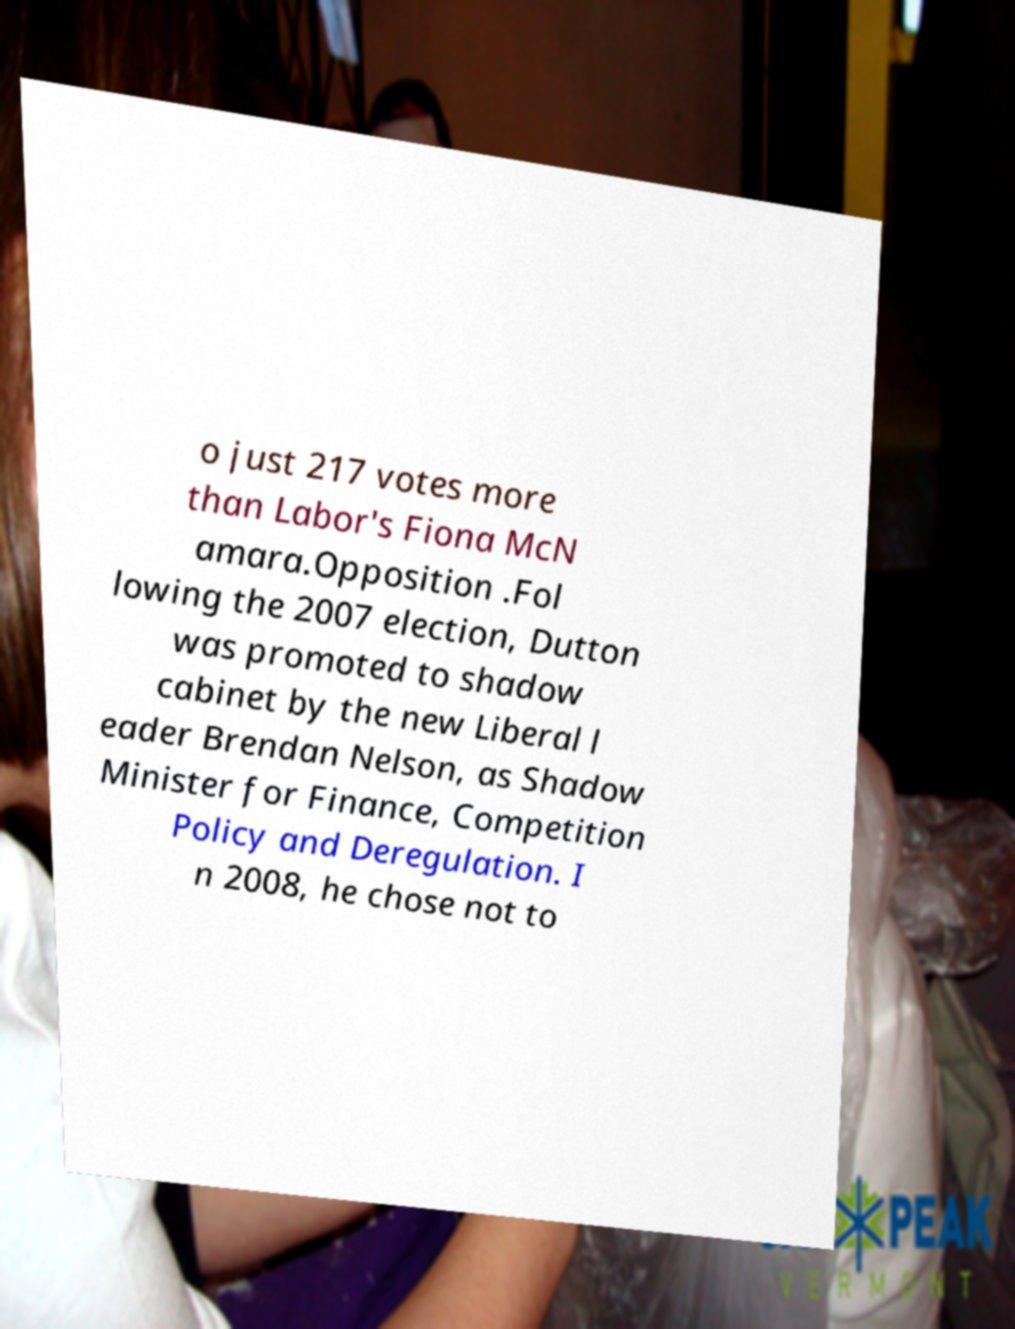Can you read and provide the text displayed in the image?This photo seems to have some interesting text. Can you extract and type it out for me? o just 217 votes more than Labor's Fiona McN amara.Opposition .Fol lowing the 2007 election, Dutton was promoted to shadow cabinet by the new Liberal l eader Brendan Nelson, as Shadow Minister for Finance, Competition Policy and Deregulation. I n 2008, he chose not to 